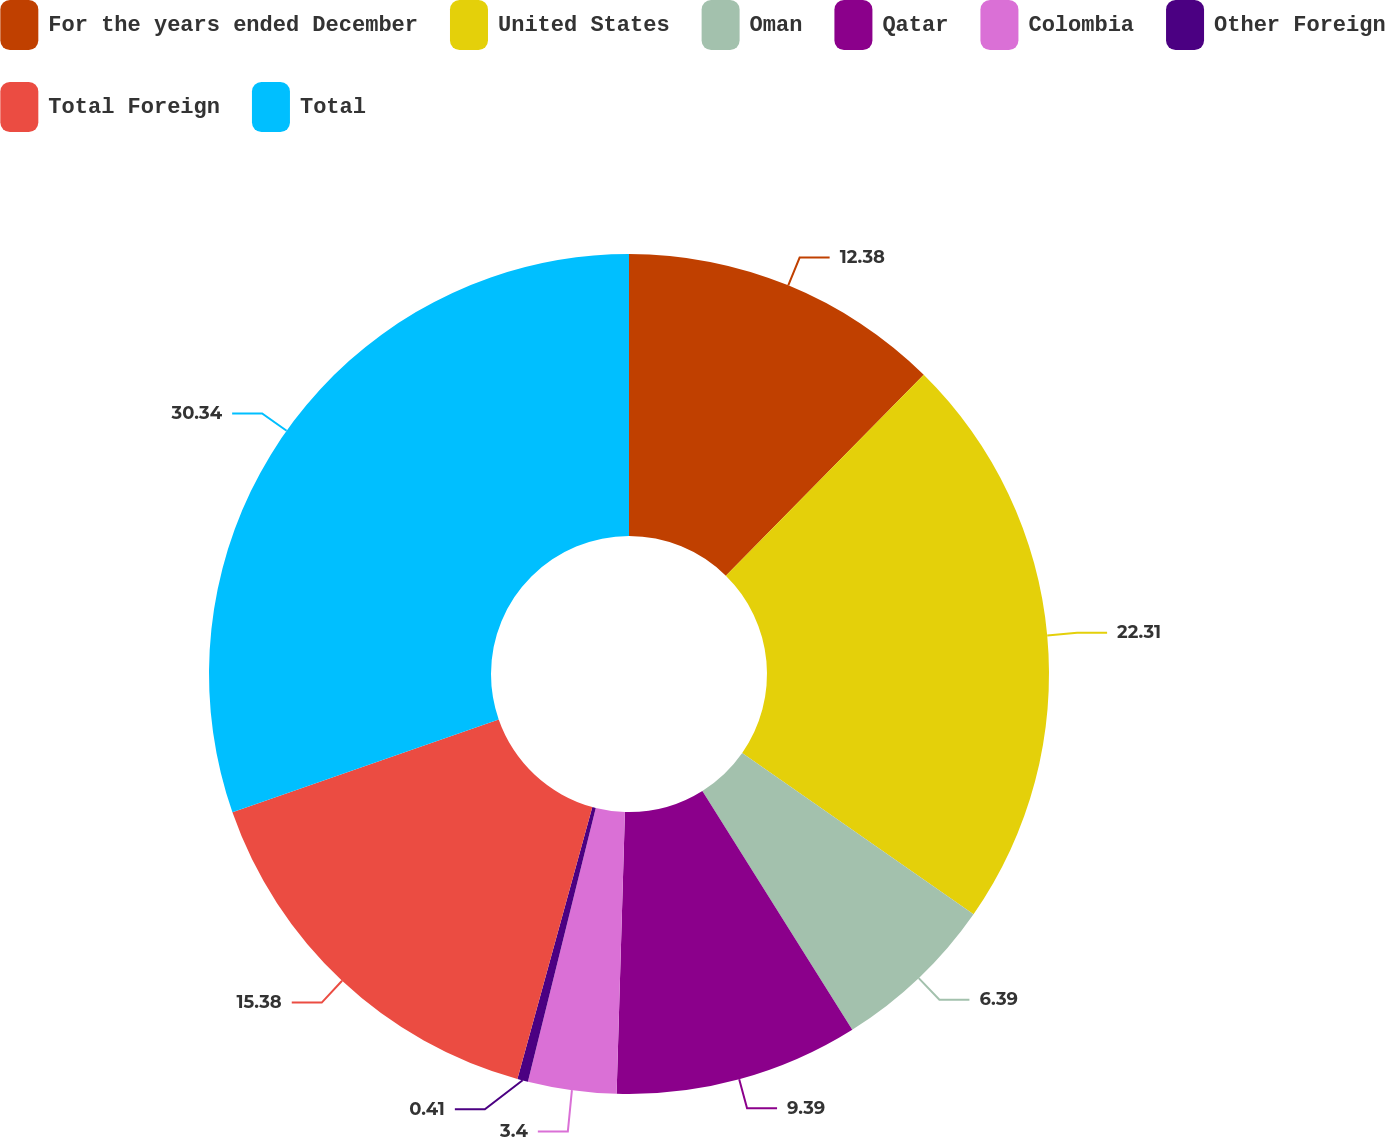Convert chart. <chart><loc_0><loc_0><loc_500><loc_500><pie_chart><fcel>For the years ended December<fcel>United States<fcel>Oman<fcel>Qatar<fcel>Colombia<fcel>Other Foreign<fcel>Total Foreign<fcel>Total<nl><fcel>12.38%<fcel>22.31%<fcel>6.39%<fcel>9.39%<fcel>3.4%<fcel>0.41%<fcel>15.38%<fcel>30.34%<nl></chart> 